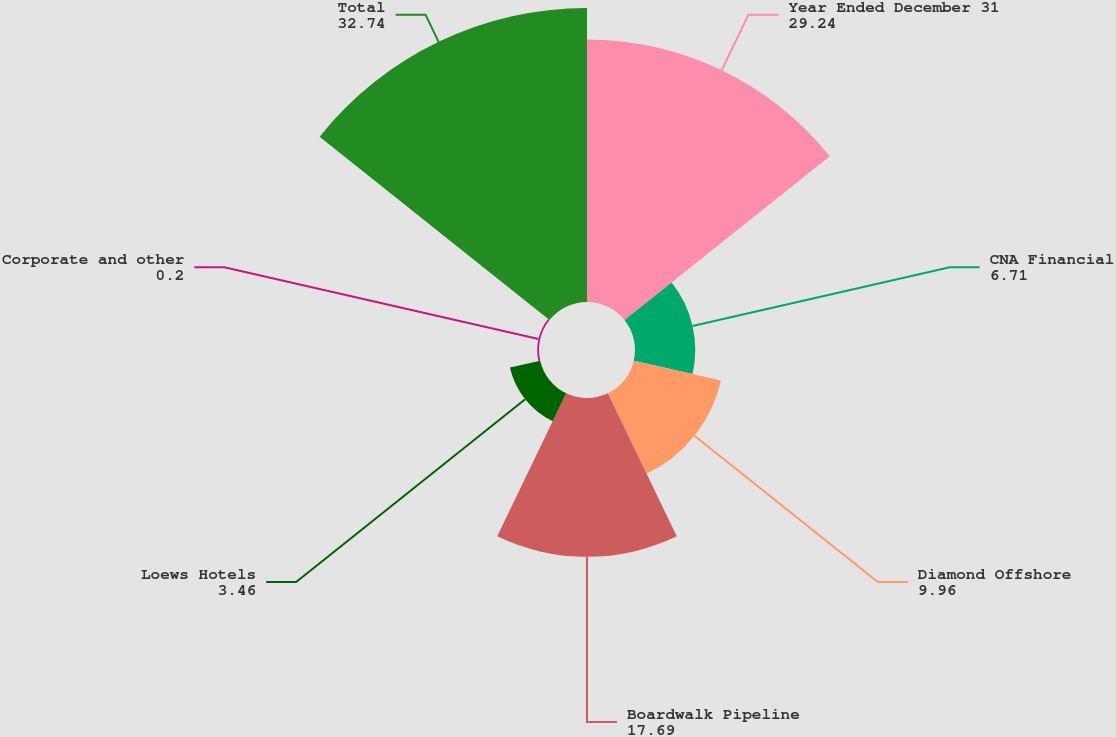Convert chart. <chart><loc_0><loc_0><loc_500><loc_500><pie_chart><fcel>Year Ended December 31<fcel>CNA Financial<fcel>Diamond Offshore<fcel>Boardwalk Pipeline<fcel>Loews Hotels<fcel>Corporate and other<fcel>Total<nl><fcel>29.24%<fcel>6.71%<fcel>9.96%<fcel>17.69%<fcel>3.46%<fcel>0.2%<fcel>32.74%<nl></chart> 